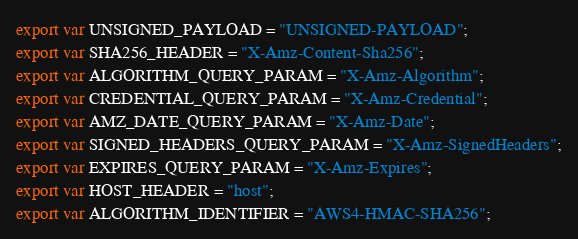<code> <loc_0><loc_0><loc_500><loc_500><_JavaScript_>export var UNSIGNED_PAYLOAD = "UNSIGNED-PAYLOAD";
export var SHA256_HEADER = "X-Amz-Content-Sha256";
export var ALGORITHM_QUERY_PARAM = "X-Amz-Algorithm";
export var CREDENTIAL_QUERY_PARAM = "X-Amz-Credential";
export var AMZ_DATE_QUERY_PARAM = "X-Amz-Date";
export var SIGNED_HEADERS_QUERY_PARAM = "X-Amz-SignedHeaders";
export var EXPIRES_QUERY_PARAM = "X-Amz-Expires";
export var HOST_HEADER = "host";
export var ALGORITHM_IDENTIFIER = "AWS4-HMAC-SHA256";</code> 